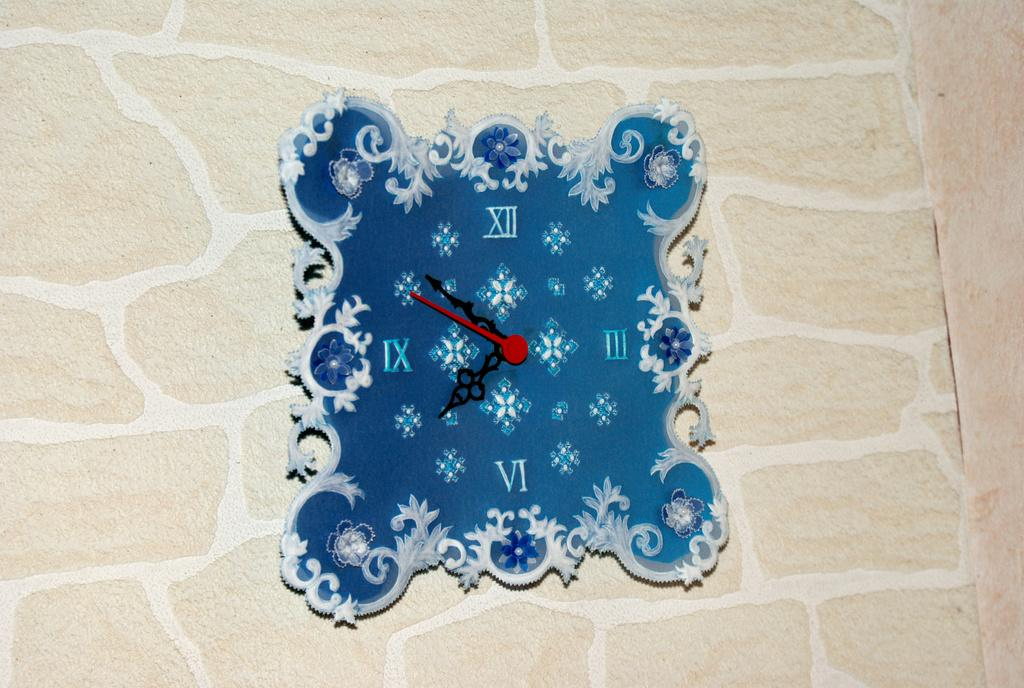Provide a one-sentence caption for the provided image. A clock with  a blue background is depicting the time as about 7:51. 